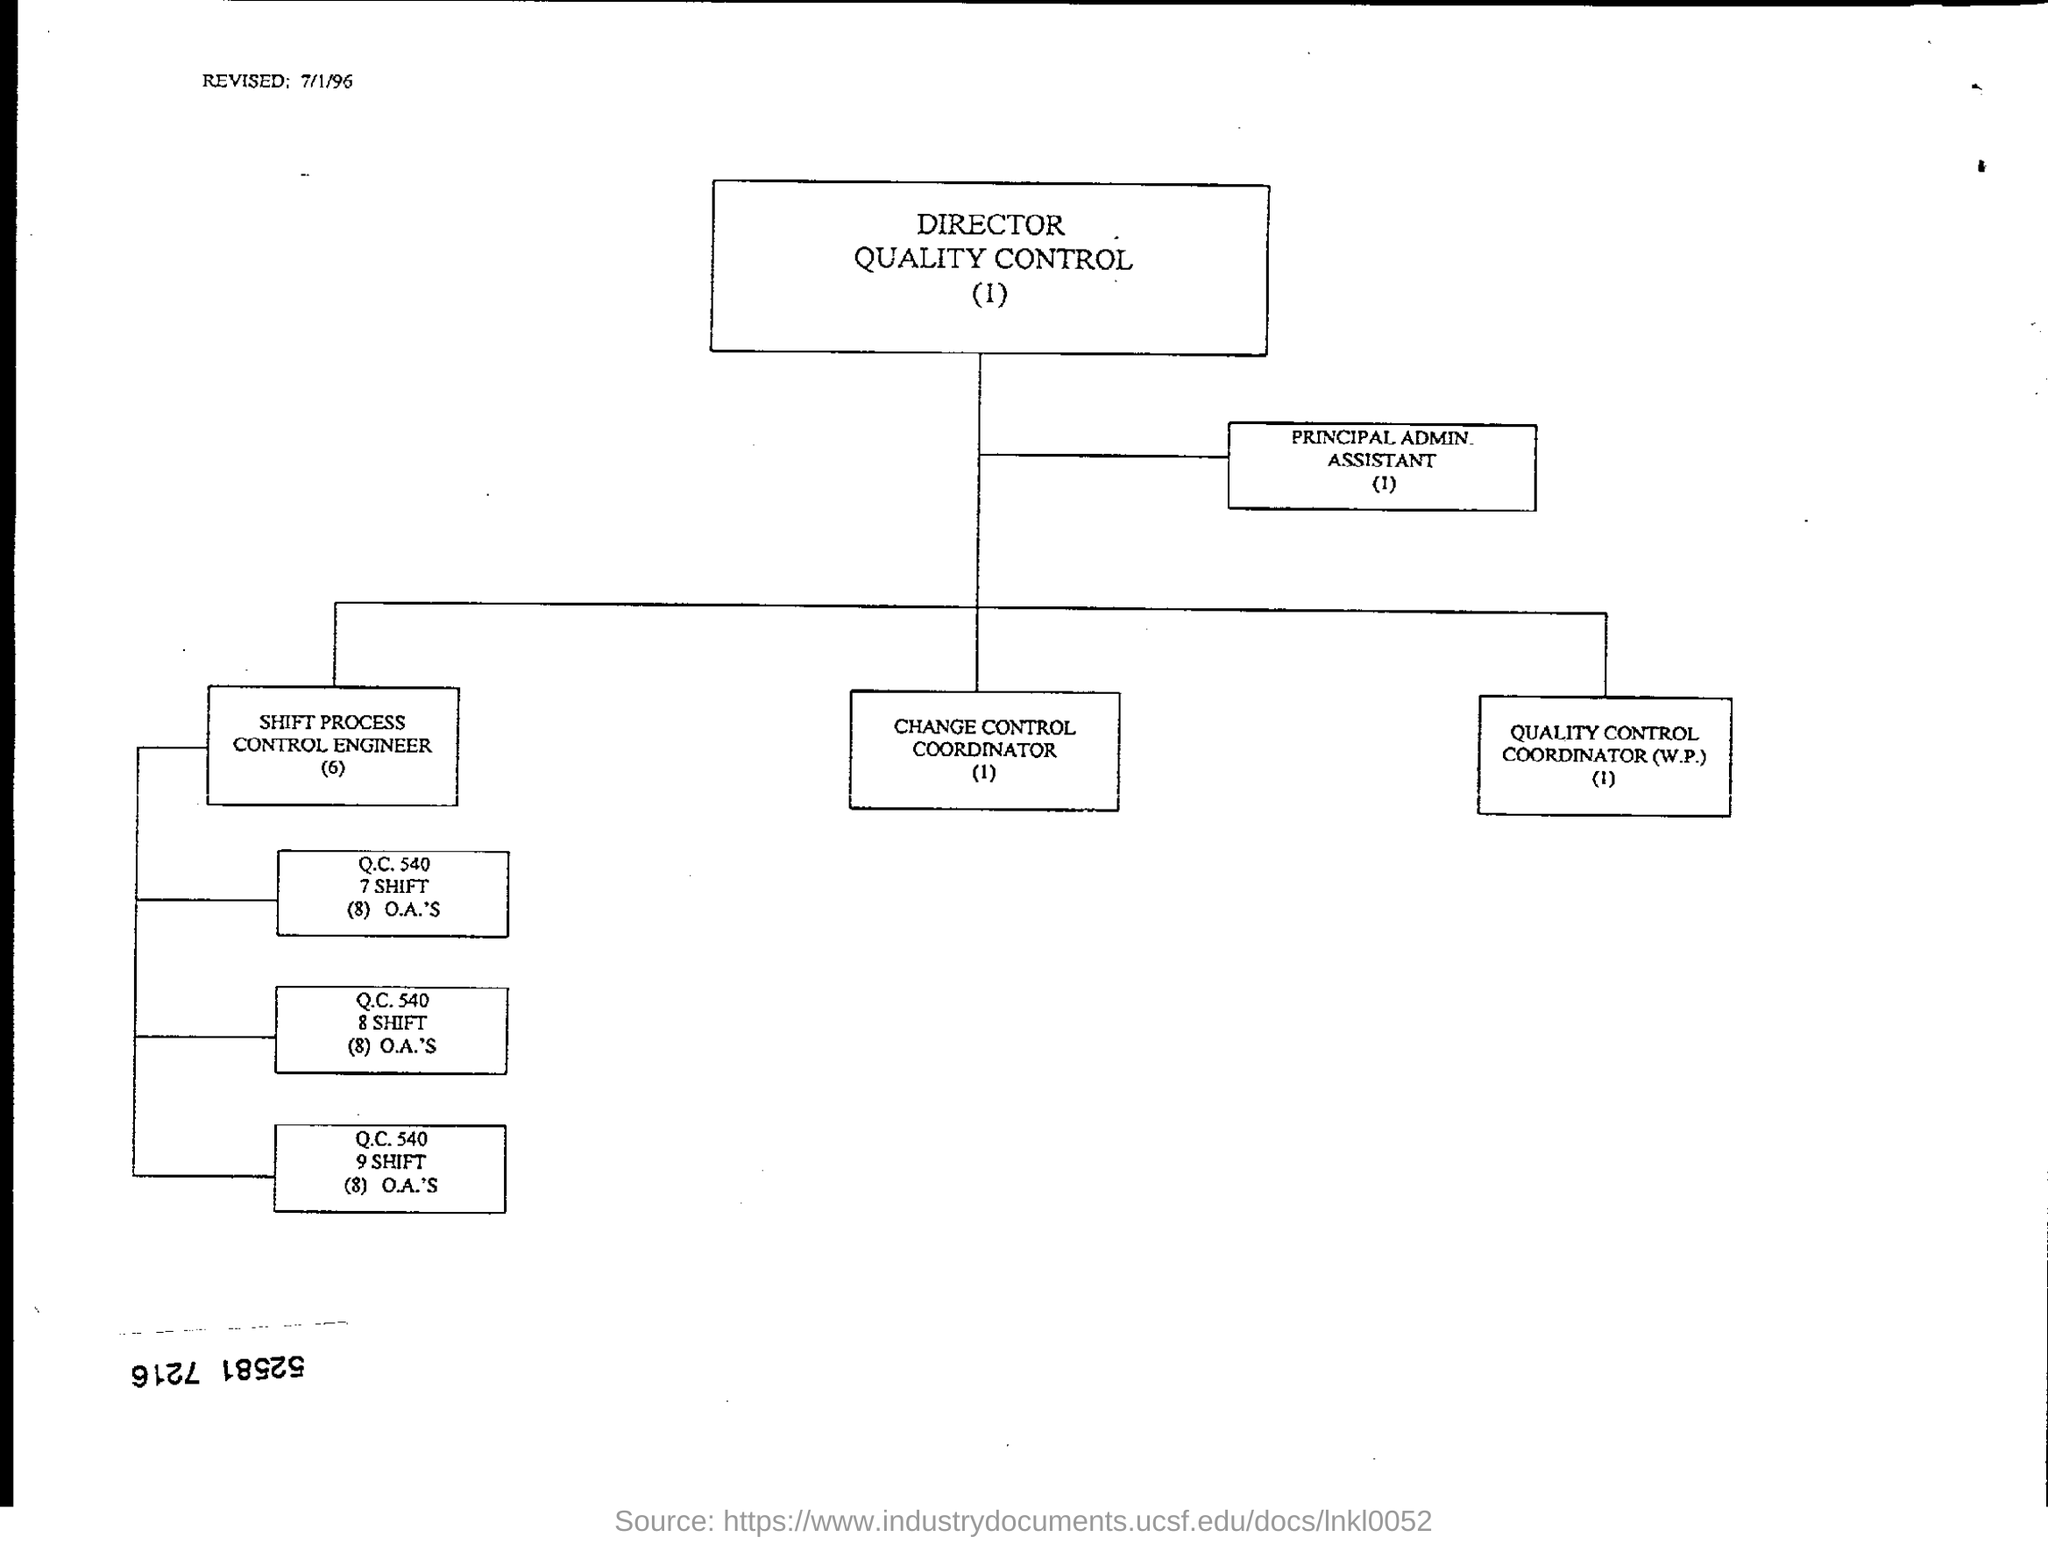What is the revised date at top left of the page ?
Provide a short and direct response. 7/1/96. 